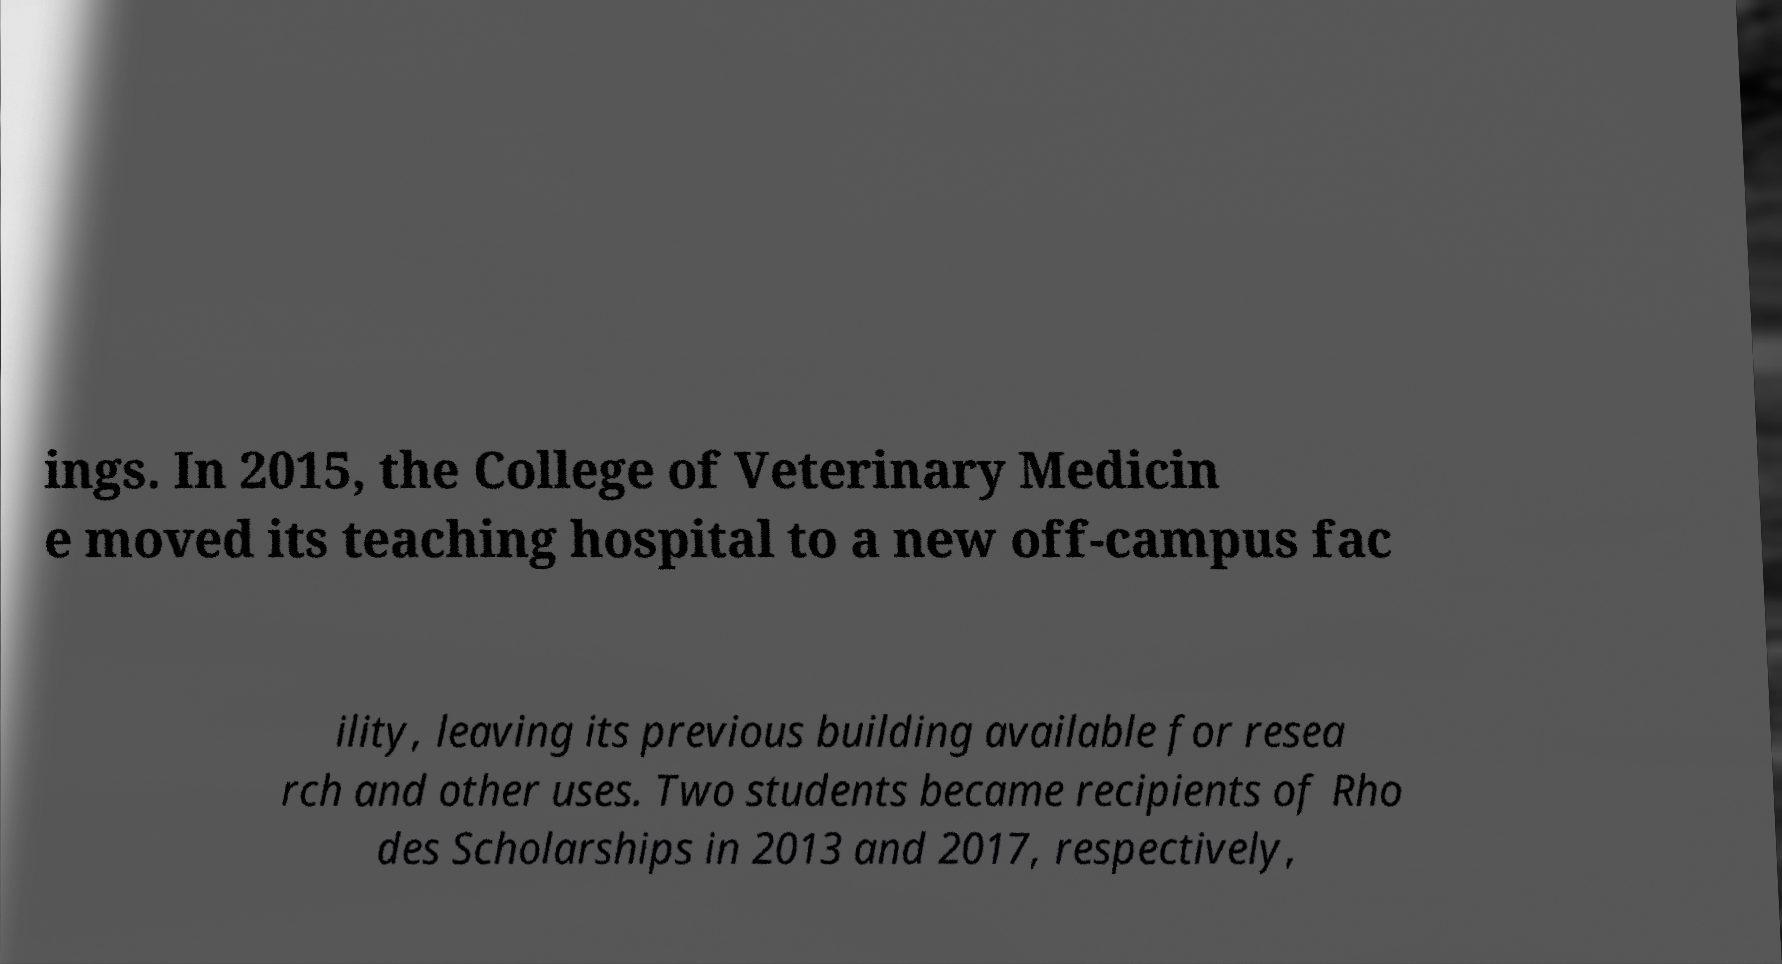For documentation purposes, I need the text within this image transcribed. Could you provide that? ings. In 2015, the College of Veterinary Medicin e moved its teaching hospital to a new off-campus fac ility, leaving its previous building available for resea rch and other uses. Two students became recipients of Rho des Scholarships in 2013 and 2017, respectively, 